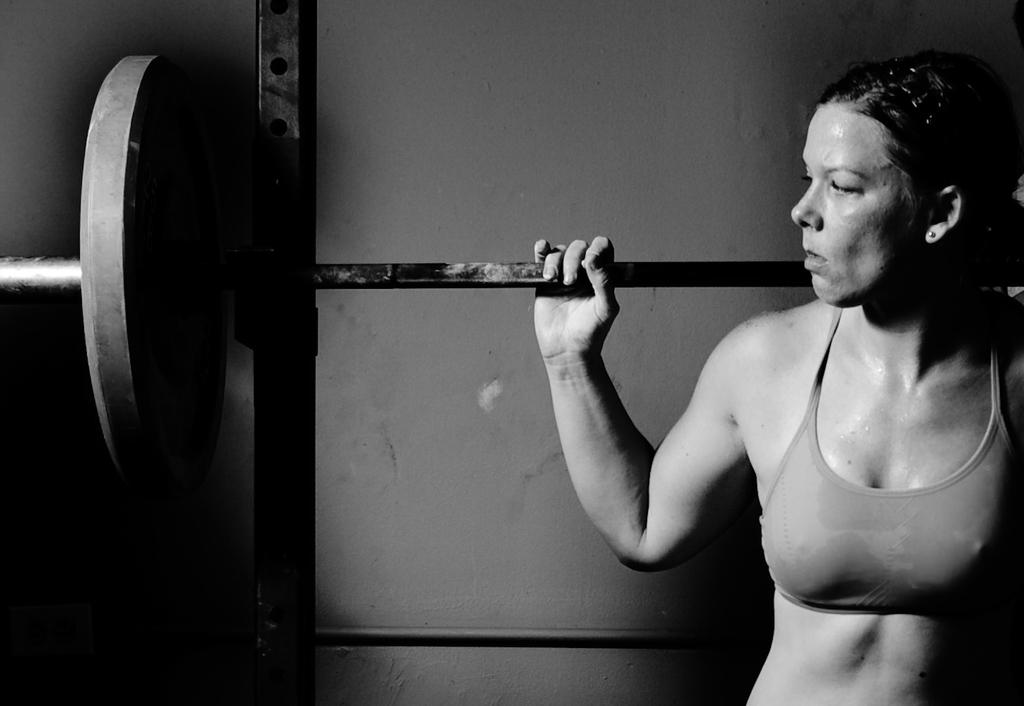What is the color scheme of the image? The image is black and white. Who is the main subject in the image? There is a woman in the image. What is the woman doing in the image? The woman is lifting weights on her shoulder. Can you tell me what the woman and the man are arguing about in the image? There is no man present in the image, and no argument is taking place. 